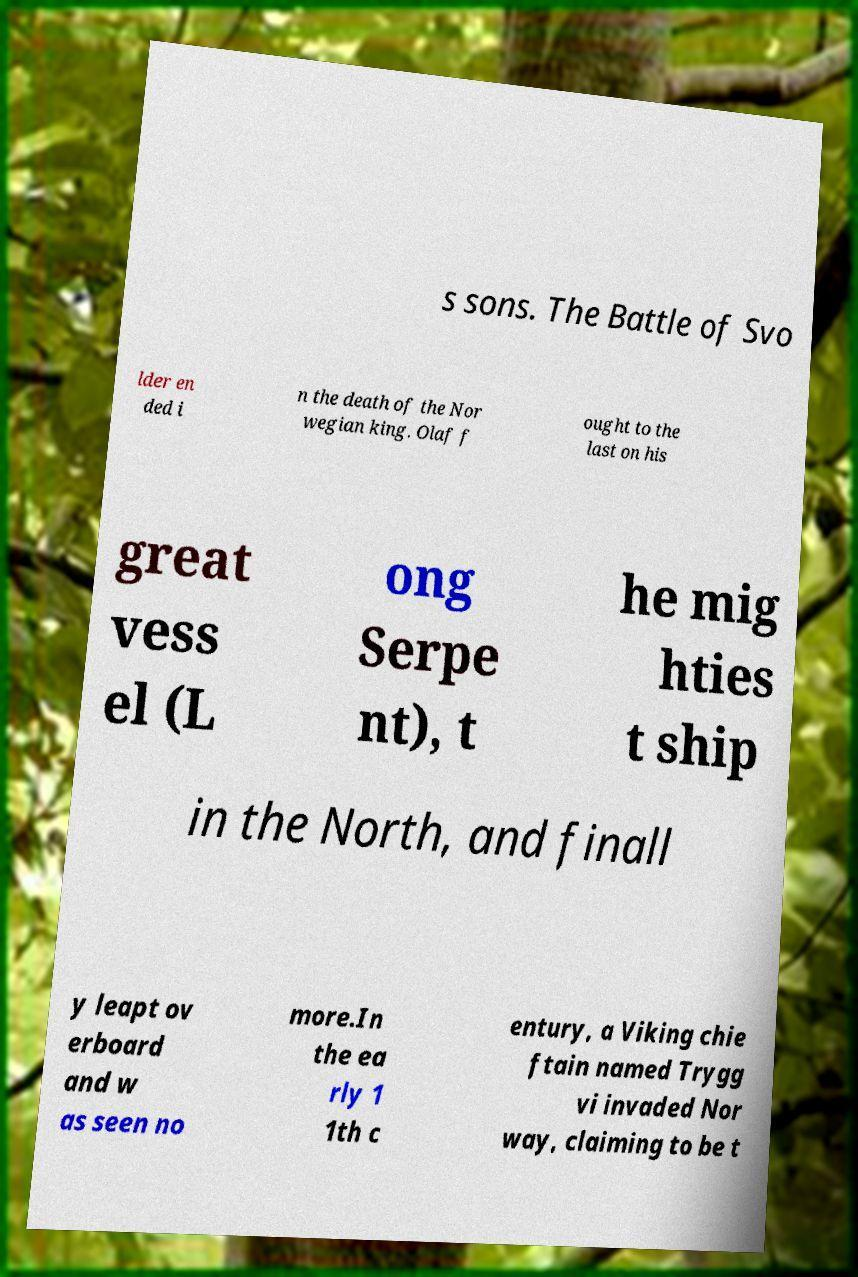Can you accurately transcribe the text from the provided image for me? s sons. The Battle of Svo lder en ded i n the death of the Nor wegian king. Olaf f ought to the last on his great vess el (L ong Serpe nt), t he mig hties t ship in the North, and finall y leapt ov erboard and w as seen no more.In the ea rly 1 1th c entury, a Viking chie ftain named Trygg vi invaded Nor way, claiming to be t 